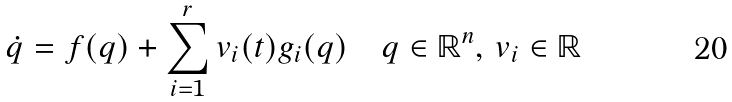<formula> <loc_0><loc_0><loc_500><loc_500>\dot { q } = f ( q ) + \sum _ { i = 1 } ^ { r } v _ { i } ( t ) g _ { i } ( q ) \quad q \in \mathbb { R } ^ { n } , \, v _ { i } \in \mathbb { R }</formula> 